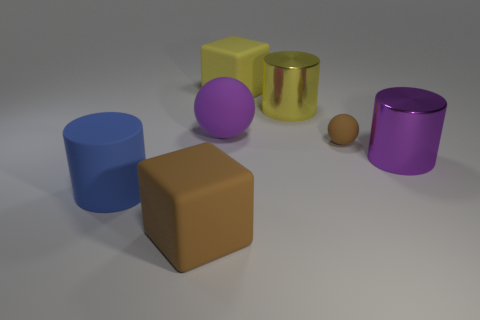Subtract all yellow shiny cylinders. How many cylinders are left? 2 Add 2 yellow matte cubes. How many objects exist? 9 Subtract all tiny blue matte things. Subtract all big brown cubes. How many objects are left? 6 Add 2 big matte blocks. How many big matte blocks are left? 4 Add 6 blue rubber objects. How many blue rubber objects exist? 7 Subtract 0 blue spheres. How many objects are left? 7 Subtract all blocks. How many objects are left? 5 Subtract all green balls. Subtract all red cylinders. How many balls are left? 2 